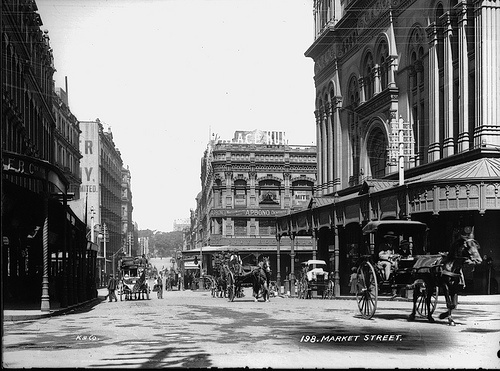Describe the objects in this image and their specific colors. I can see horse in black, gray, darkgray, and lightgray tones, horse in black, gray, darkgray, and lightgray tones, people in black, darkgray, gray, and lightgray tones, people in black, gray, darkgray, and white tones, and horse in black, gray, darkgray, and lightgray tones in this image. 